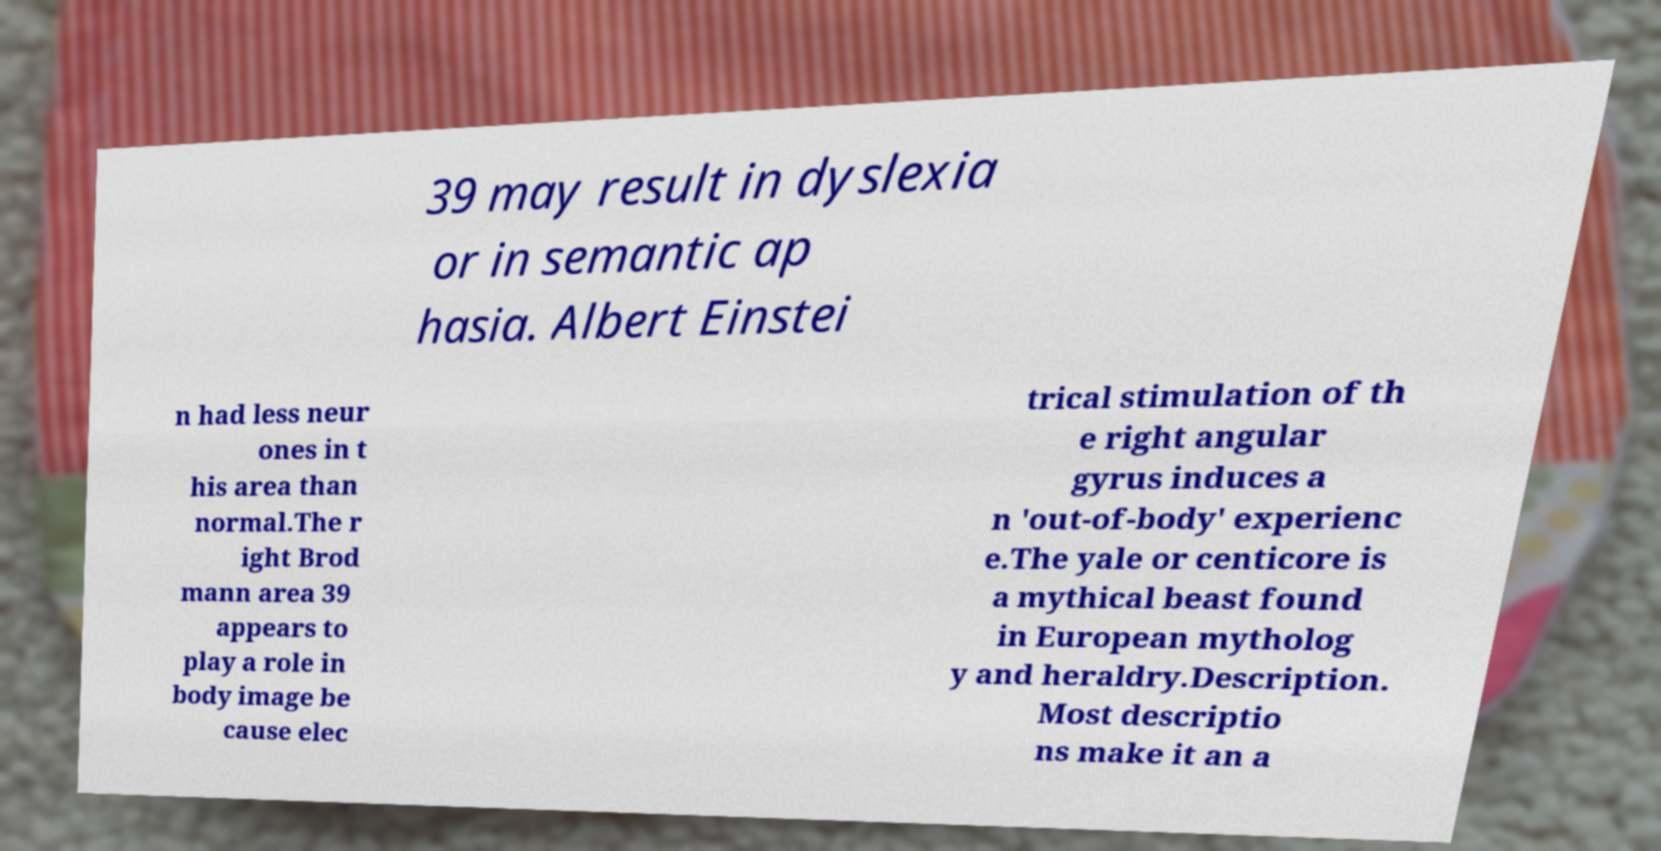Can you accurately transcribe the text from the provided image for me? 39 may result in dyslexia or in semantic ap hasia. Albert Einstei n had less neur ones in t his area than normal.The r ight Brod mann area 39 appears to play a role in body image be cause elec trical stimulation of th e right angular gyrus induces a n 'out-of-body' experienc e.The yale or centicore is a mythical beast found in European mytholog y and heraldry.Description. Most descriptio ns make it an a 